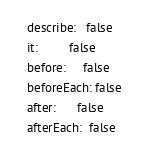<code> <loc_0><loc_0><loc_500><loc_500><_YAML_>  describe:   false
  it:         false
  before:     false
  beforeEach: false
  after:      false
  afterEach:  false</code> 